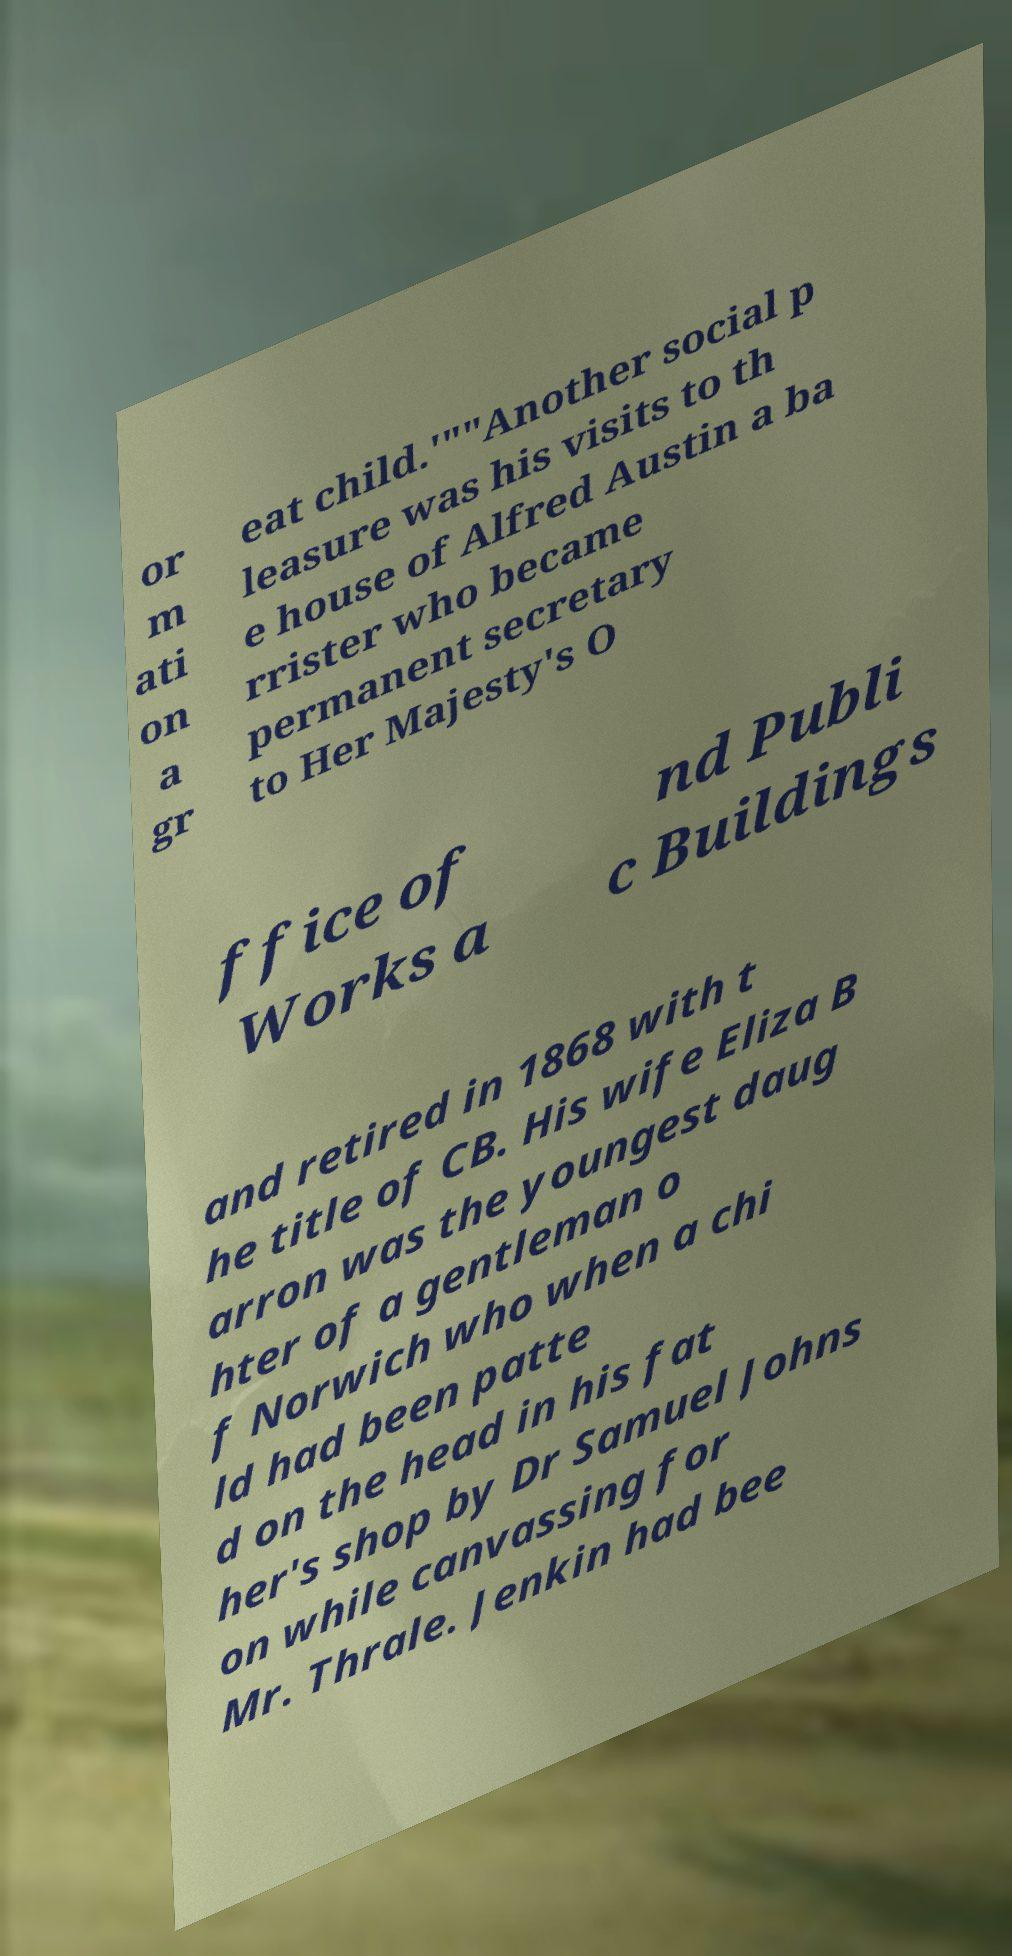Can you read and provide the text displayed in the image?This photo seems to have some interesting text. Can you extract and type it out for me? or m ati on a gr eat child.'""Another social p leasure was his visits to th e house of Alfred Austin a ba rrister who became permanent secretary to Her Majesty's O ffice of Works a nd Publi c Buildings and retired in 1868 with t he title of CB. His wife Eliza B arron was the youngest daug hter of a gentleman o f Norwich who when a chi ld had been patte d on the head in his fat her's shop by Dr Samuel Johns on while canvassing for Mr. Thrale. Jenkin had bee 